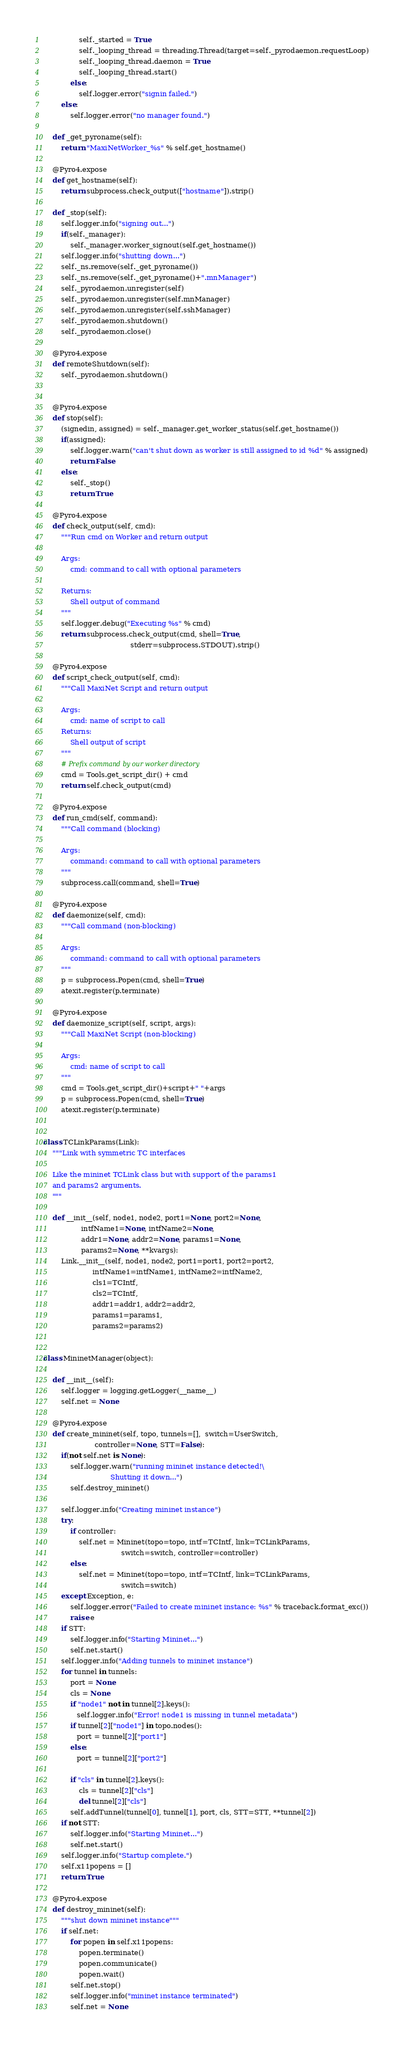Convert code to text. <code><loc_0><loc_0><loc_500><loc_500><_Python_>                self._started = True
                self._looping_thread = threading.Thread(target=self._pyrodaemon.requestLoop)
                self._looping_thread.daemon = True
                self._looping_thread.start()
            else:
                self.logger.error("signin failed.")
        else:
            self.logger.error("no manager found.")

    def _get_pyroname(self):
        return "MaxiNetWorker_%s" % self.get_hostname()

    @Pyro4.expose
    def get_hostname(self):
        return subprocess.check_output(["hostname"]).strip()

    def _stop(self):
        self.logger.info("signing out...")
        if(self._manager):
            self._manager.worker_signout(self.get_hostname())
        self.logger.info("shutting down...")
        self._ns.remove(self._get_pyroname())
        self._ns.remove(self._get_pyroname()+".mnManager")
        self._pyrodaemon.unregister(self)
        self._pyrodaemon.unregister(self.mnManager)
        self._pyrodaemon.unregister(self.sshManager)
        self._pyrodaemon.shutdown()
        self._pyrodaemon.close()

    @Pyro4.expose
    def remoteShutdown(self):
        self._pyrodaemon.shutdown()


    @Pyro4.expose
    def stop(self):
        (signedin, assigned) = self._manager.get_worker_status(self.get_hostname())
        if(assigned):
            self.logger.warn("can't shut down as worker is still assigned to id %d" % assigned)
            return False
        else:
            self._stop()
            return True

    @Pyro4.expose
    def check_output(self, cmd):
        """Run cmd on Worker and return output

        Args:
            cmd: command to call with optional parameters

        Returns:
            Shell output of command
        """
        self.logger.debug("Executing %s" % cmd)
        return subprocess.check_output(cmd, shell=True,
                                       stderr=subprocess.STDOUT).strip()

    @Pyro4.expose
    def script_check_output(self, cmd):
        """Call MaxiNet Script and return output

        Args:
            cmd: name of script to call
        Returns:
            Shell output of script
        """
        # Prefix command by our worker directory
        cmd = Tools.get_script_dir() + cmd
        return self.check_output(cmd)

    @Pyro4.expose
    def run_cmd(self, command):
        """Call command (blocking)

        Args:
            command: command to call with optional parameters
        """
        subprocess.call(command, shell=True)

    @Pyro4.expose
    def daemonize(self, cmd):
        """Call command (non-blocking)

        Args:
            command: command to call with optional parameters
        """
        p = subprocess.Popen(cmd, shell=True)
        atexit.register(p.terminate)

    @Pyro4.expose
    def daemonize_script(self, script, args):
        """Call MaxiNet Script (non-blocking)

        Args:
            cmd: name of script to call
        """
        cmd = Tools.get_script_dir()+script+" "+args
        p = subprocess.Popen(cmd, shell=True)
        atexit.register(p.terminate)


class TCLinkParams(Link):
    """Link with symmetric TC interfaces

    Like the mininet TCLink class but with support of the params1
    and params2 arguments.
    """

    def __init__(self, node1, node2, port1=None, port2=None,
                 intfName1=None, intfName2=None,
                 addr1=None, addr2=None, params1=None,
                 params2=None, **kvargs):
        Link.__init__(self, node1, node2, port1=port1, port2=port2,
                      intfName1=intfName1, intfName2=intfName2,
                      cls1=TCIntf,
                      cls2=TCIntf,
                      addr1=addr1, addr2=addr2,
                      params1=params1,
                      params2=params2)


class MininetManager(object):

    def __init__(self):
        self.logger = logging.getLogger(__name__)
        self.net = None

    @Pyro4.expose
    def create_mininet(self, topo, tunnels=[],  switch=UserSwitch,
                       controller=None, STT=False):
        if(not self.net is None):
            self.logger.warn("running mininet instance detected!\
                              Shutting it down...")
            self.destroy_mininet()

        self.logger.info("Creating mininet instance")
        try:
            if controller:
                self.net = Mininet(topo=topo, intf=TCIntf, link=TCLinkParams,
                                   switch=switch, controller=controller)
            else:
                self.net = Mininet(topo=topo, intf=TCIntf, link=TCLinkParams,
                                   switch=switch)
        except Exception, e:
            self.logger.error("Failed to create mininet instance: %s" % traceback.format_exc())
            raise e
        if STT:
            self.logger.info("Starting Mininet...")
            self.net.start()
        self.logger.info("Adding tunnels to mininet instance")
        for tunnel in tunnels:
            port = None
            cls = None
            if "node1" not in tunnel[2].keys():
               self.logger.info("Error! node1 is missing in tunnel metadata")
            if tunnel[2]["node1"] in topo.nodes():
               port = tunnel[2]["port1"]
            else:
               port = tunnel[2]["port2"]

            if "cls" in tunnel[2].keys():
                cls = tunnel[2]["cls"]
                del tunnel[2]["cls"]
            self.addTunnel(tunnel[0], tunnel[1], port, cls, STT=STT, **tunnel[2])
        if not STT:
            self.logger.info("Starting Mininet...")
            self.net.start()
        self.logger.info("Startup complete.")
        self.x11popens = []
        return True

    @Pyro4.expose
    def destroy_mininet(self):
        """shut down mininet instance"""
        if self.net:
            for popen in self.x11popens:
                popen.terminate()
                popen.communicate()
                popen.wait()
            self.net.stop()
            self.logger.info("mininet instance terminated")
            self.net = None
</code> 